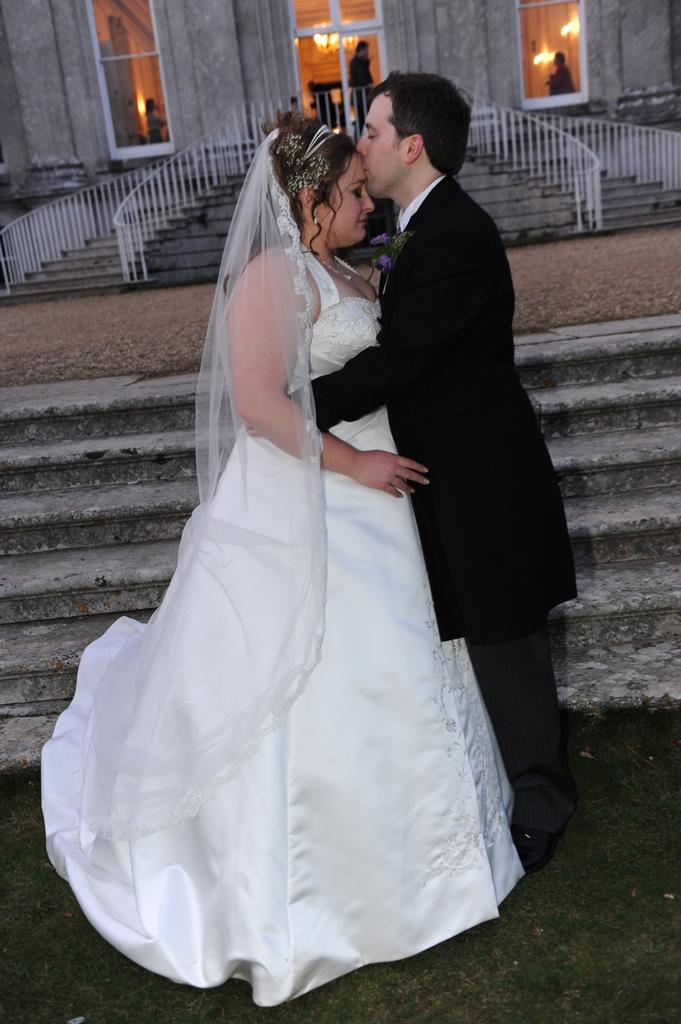Who is present in the image? There is a couple in the image. What is one person doing to the girl? One person is kissing the forehead of the girl. What architectural feature can be seen in the image? There are stairs visible in the image. What type of building do the stairs belong to? The stairs are part of a church. What type of bears can be seen playing in the rainstorm in the image? There are no bears or rainstorm present in the image. 